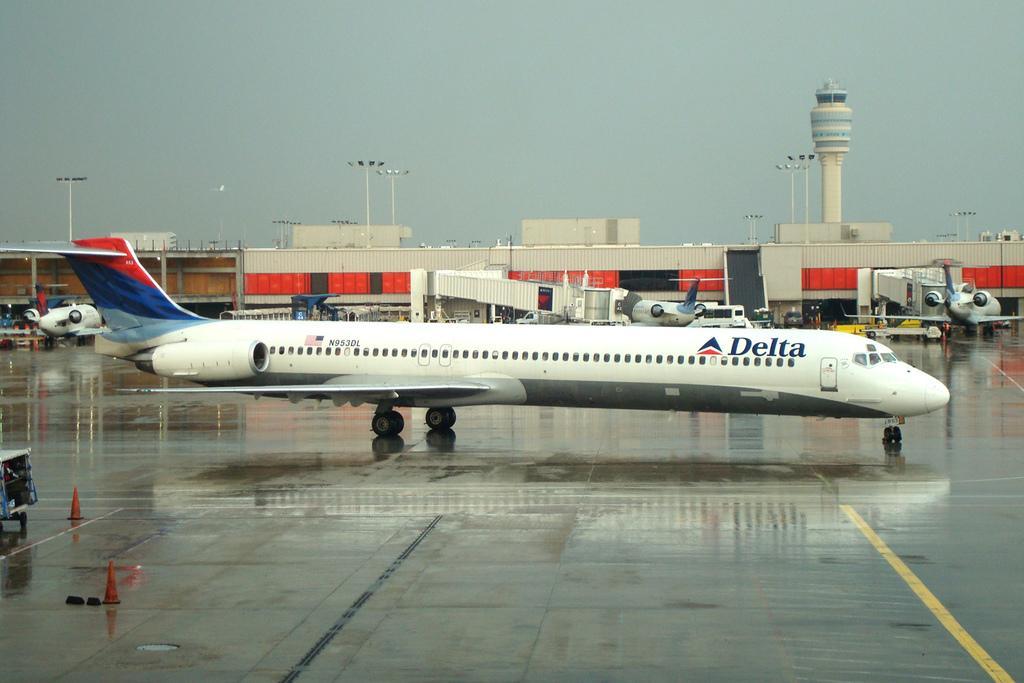Can you describe this image briefly? In this picture we can see airplanes, vehicles, traffic cones on the road, building, poles, lights and tower. In the background of the image we can see the sky. 